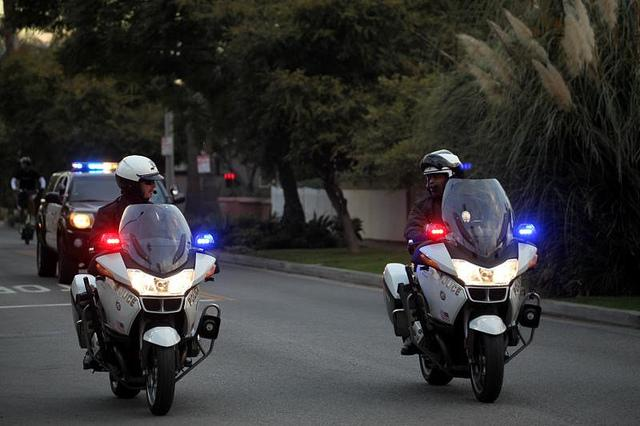What color is the officer riding on the police motorcycle to the left?

Choices:
A) black
B) green
C) white
D) purple white 